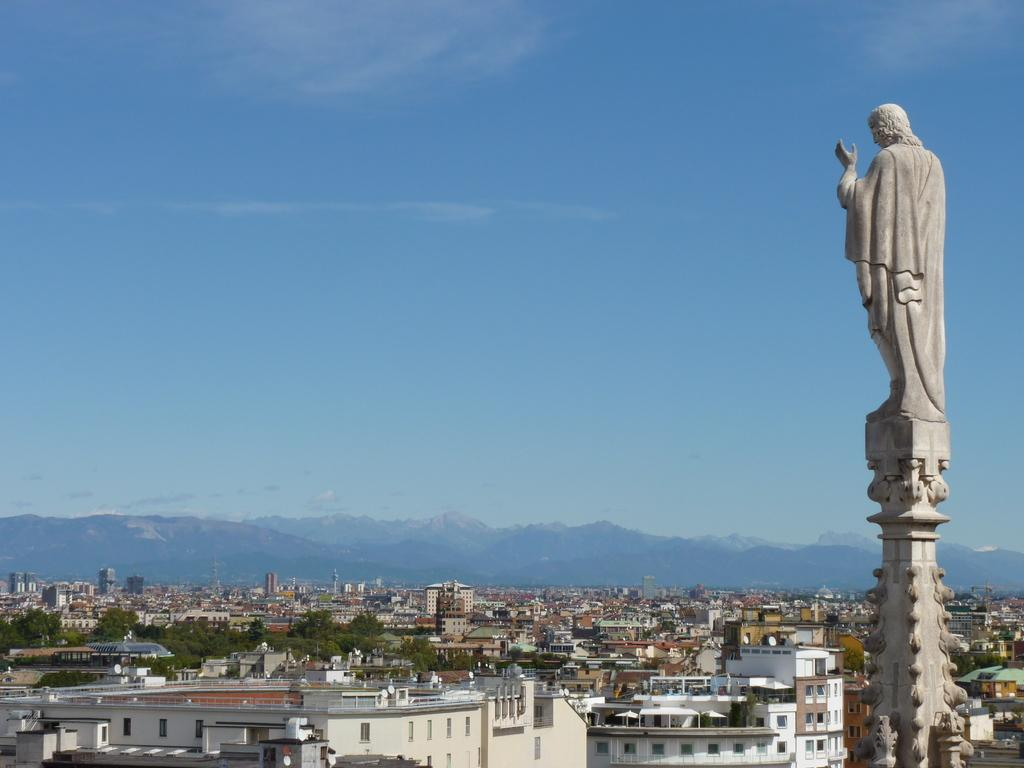What types of structures are present in the image? There are buildings and houses in the image. What natural elements can be seen in the image? There are trees and mountains in the image. What is visible in the sky in the image? The sky is visible in the image. Where is the statue located in the image? The statue is on the right side of the image. What type of tank is visible in the image? There is no tank present in the image. What suggestion is being made by the actor in the image? There is no actor present in the image, so no suggestion can be made. 